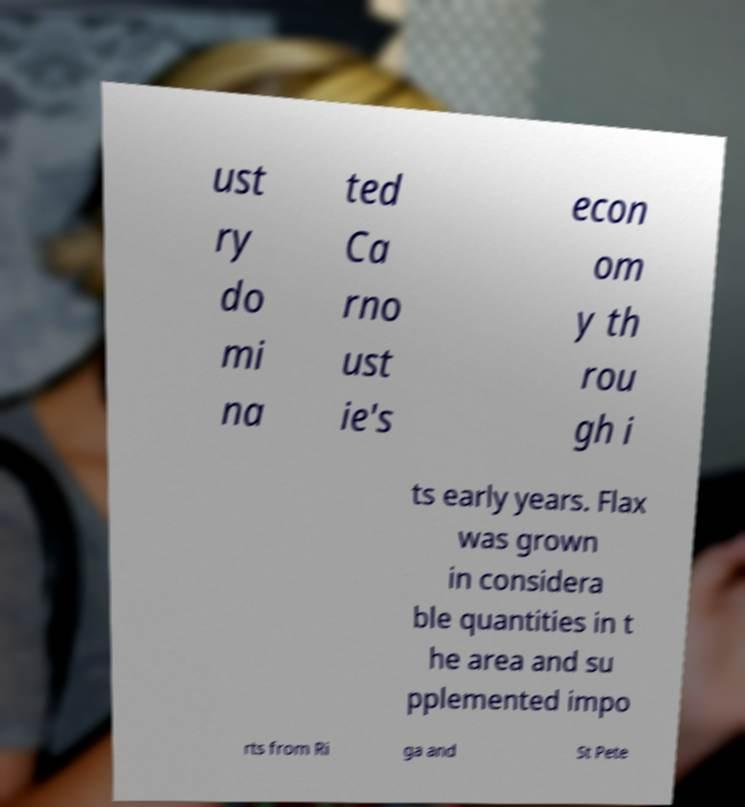There's text embedded in this image that I need extracted. Can you transcribe it verbatim? ust ry do mi na ted Ca rno ust ie's econ om y th rou gh i ts early years. Flax was grown in considera ble quantities in t he area and su pplemented impo rts from Ri ga and St Pete 